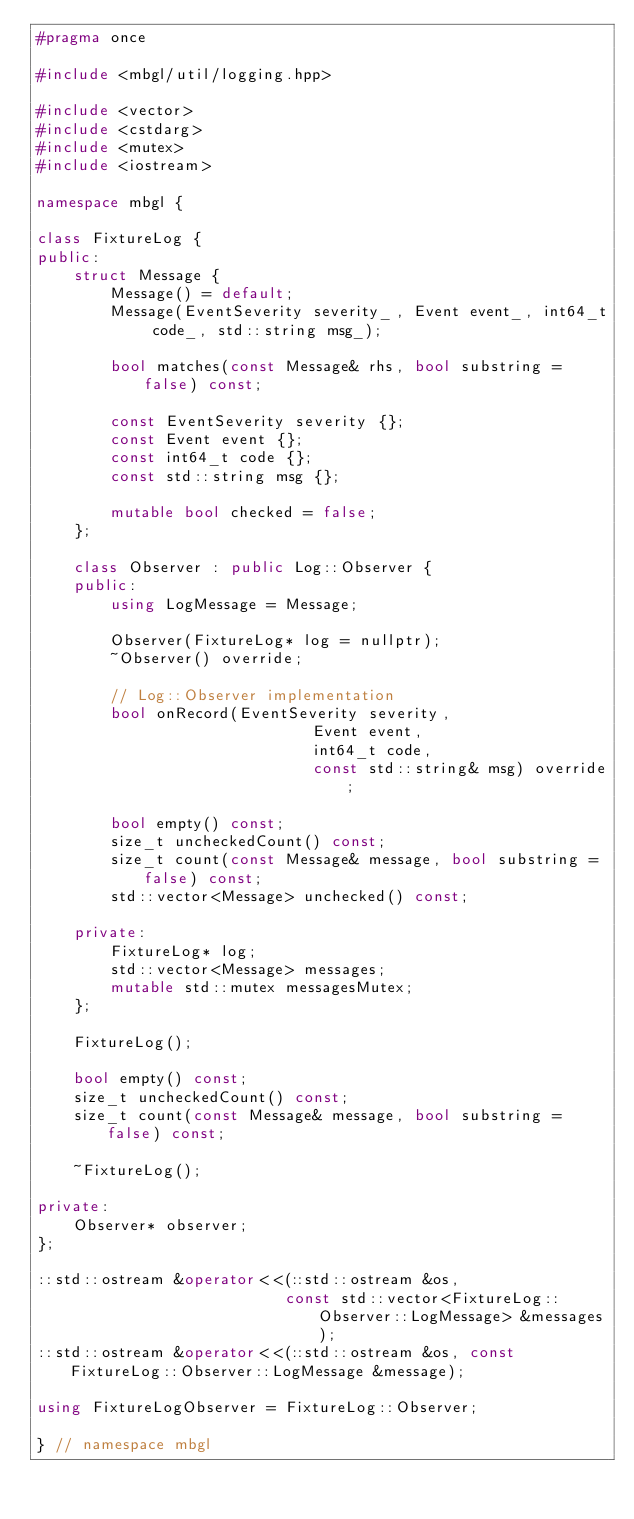<code> <loc_0><loc_0><loc_500><loc_500><_C++_>#pragma once

#include <mbgl/util/logging.hpp>

#include <vector>
#include <cstdarg>
#include <mutex>
#include <iostream>

namespace mbgl {

class FixtureLog {
public:
    struct Message {
        Message() = default;
        Message(EventSeverity severity_, Event event_, int64_t code_, std::string msg_);

        bool matches(const Message& rhs, bool substring = false) const;

        const EventSeverity severity {};
        const Event event {};
        const int64_t code {};
        const std::string msg {};

        mutable bool checked = false;
    };

    class Observer : public Log::Observer {
    public:
        using LogMessage = Message;

        Observer(FixtureLog* log = nullptr);
        ~Observer() override;

        // Log::Observer implementation
        bool onRecord(EventSeverity severity,
                              Event event,
                              int64_t code,
                              const std::string& msg) override;

        bool empty() const;
        size_t uncheckedCount() const;
        size_t count(const Message& message, bool substring = false) const;
        std::vector<Message> unchecked() const;

    private:
        FixtureLog* log;
        std::vector<Message> messages;
        mutable std::mutex messagesMutex;
    };

    FixtureLog();

    bool empty() const;
    size_t uncheckedCount() const;
    size_t count(const Message& message, bool substring = false) const;

    ~FixtureLog();

private:
    Observer* observer;
};

::std::ostream &operator<<(::std::ostream &os,
                           const std::vector<FixtureLog::Observer::LogMessage> &messages);
::std::ostream &operator<<(::std::ostream &os, const FixtureLog::Observer::LogMessage &message);

using FixtureLogObserver = FixtureLog::Observer;

} // namespace mbgl
</code> 